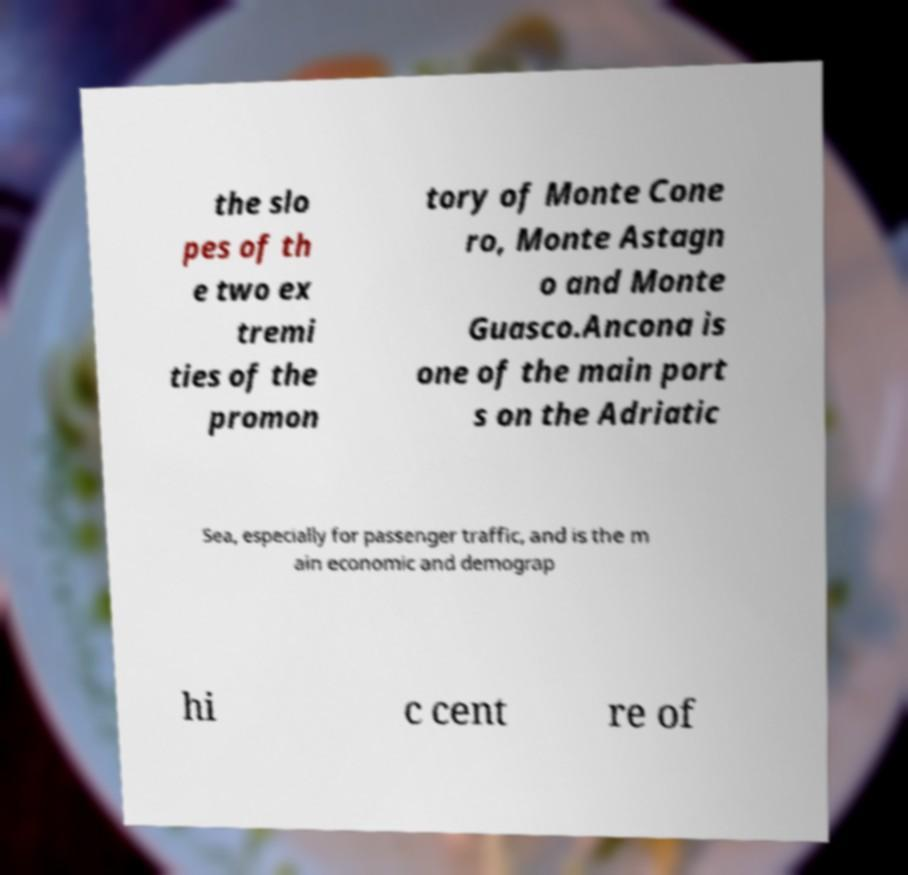Please identify and transcribe the text found in this image. the slo pes of th e two ex tremi ties of the promon tory of Monte Cone ro, Monte Astagn o and Monte Guasco.Ancona is one of the main port s on the Adriatic Sea, especially for passenger traffic, and is the m ain economic and demograp hi c cent re of 